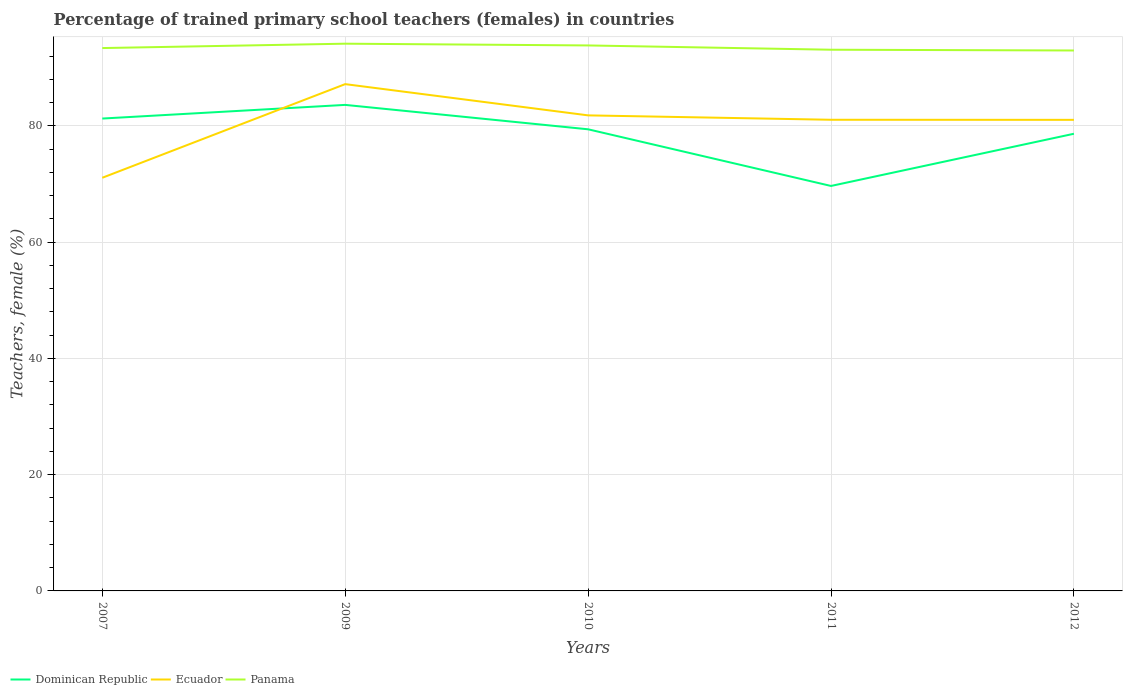Is the number of lines equal to the number of legend labels?
Give a very brief answer. Yes. Across all years, what is the maximum percentage of trained primary school teachers (females) in Panama?
Your answer should be very brief. 92.97. What is the total percentage of trained primary school teachers (females) in Ecuador in the graph?
Ensure brevity in your answer.  0.75. What is the difference between the highest and the second highest percentage of trained primary school teachers (females) in Ecuador?
Make the answer very short. 16.11. Is the percentage of trained primary school teachers (females) in Panama strictly greater than the percentage of trained primary school teachers (females) in Ecuador over the years?
Give a very brief answer. No. How many lines are there?
Your answer should be very brief. 3. How many years are there in the graph?
Offer a terse response. 5. Are the values on the major ticks of Y-axis written in scientific E-notation?
Make the answer very short. No. Does the graph contain any zero values?
Give a very brief answer. No. Does the graph contain grids?
Make the answer very short. Yes. How are the legend labels stacked?
Provide a succinct answer. Horizontal. What is the title of the graph?
Make the answer very short. Percentage of trained primary school teachers (females) in countries. Does "Bolivia" appear as one of the legend labels in the graph?
Your response must be concise. No. What is the label or title of the X-axis?
Give a very brief answer. Years. What is the label or title of the Y-axis?
Offer a terse response. Teachers, female (%). What is the Teachers, female (%) of Dominican Republic in 2007?
Offer a terse response. 81.26. What is the Teachers, female (%) of Ecuador in 2007?
Your answer should be compact. 71.07. What is the Teachers, female (%) of Panama in 2007?
Offer a very short reply. 93.39. What is the Teachers, female (%) in Dominican Republic in 2009?
Your answer should be very brief. 83.61. What is the Teachers, female (%) of Ecuador in 2009?
Provide a succinct answer. 87.18. What is the Teachers, female (%) of Panama in 2009?
Give a very brief answer. 94.14. What is the Teachers, female (%) of Dominican Republic in 2010?
Ensure brevity in your answer.  79.41. What is the Teachers, female (%) in Ecuador in 2010?
Your answer should be compact. 81.81. What is the Teachers, female (%) in Panama in 2010?
Provide a short and direct response. 93.84. What is the Teachers, female (%) in Dominican Republic in 2011?
Your response must be concise. 69.66. What is the Teachers, female (%) in Ecuador in 2011?
Your response must be concise. 81.05. What is the Teachers, female (%) in Panama in 2011?
Keep it short and to the point. 93.1. What is the Teachers, female (%) of Dominican Republic in 2012?
Make the answer very short. 78.64. What is the Teachers, female (%) in Ecuador in 2012?
Keep it short and to the point. 81.04. What is the Teachers, female (%) of Panama in 2012?
Your response must be concise. 92.97. Across all years, what is the maximum Teachers, female (%) of Dominican Republic?
Provide a short and direct response. 83.61. Across all years, what is the maximum Teachers, female (%) of Ecuador?
Ensure brevity in your answer.  87.18. Across all years, what is the maximum Teachers, female (%) of Panama?
Provide a short and direct response. 94.14. Across all years, what is the minimum Teachers, female (%) in Dominican Republic?
Your answer should be compact. 69.66. Across all years, what is the minimum Teachers, female (%) of Ecuador?
Your answer should be very brief. 71.07. Across all years, what is the minimum Teachers, female (%) of Panama?
Your answer should be compact. 92.97. What is the total Teachers, female (%) in Dominican Republic in the graph?
Provide a succinct answer. 392.59. What is the total Teachers, female (%) in Ecuador in the graph?
Provide a short and direct response. 402.15. What is the total Teachers, female (%) in Panama in the graph?
Ensure brevity in your answer.  467.43. What is the difference between the Teachers, female (%) in Dominican Republic in 2007 and that in 2009?
Offer a terse response. -2.35. What is the difference between the Teachers, female (%) of Ecuador in 2007 and that in 2009?
Offer a terse response. -16.11. What is the difference between the Teachers, female (%) in Panama in 2007 and that in 2009?
Keep it short and to the point. -0.75. What is the difference between the Teachers, female (%) of Dominican Republic in 2007 and that in 2010?
Provide a short and direct response. 1.85. What is the difference between the Teachers, female (%) in Ecuador in 2007 and that in 2010?
Make the answer very short. -10.73. What is the difference between the Teachers, female (%) of Panama in 2007 and that in 2010?
Keep it short and to the point. -0.45. What is the difference between the Teachers, female (%) in Dominican Republic in 2007 and that in 2011?
Ensure brevity in your answer.  11.6. What is the difference between the Teachers, female (%) in Ecuador in 2007 and that in 2011?
Your answer should be compact. -9.98. What is the difference between the Teachers, female (%) in Panama in 2007 and that in 2011?
Ensure brevity in your answer.  0.29. What is the difference between the Teachers, female (%) in Dominican Republic in 2007 and that in 2012?
Make the answer very short. 2.62. What is the difference between the Teachers, female (%) of Ecuador in 2007 and that in 2012?
Provide a succinct answer. -9.97. What is the difference between the Teachers, female (%) in Panama in 2007 and that in 2012?
Your answer should be compact. 0.42. What is the difference between the Teachers, female (%) in Dominican Republic in 2009 and that in 2010?
Offer a terse response. 4.2. What is the difference between the Teachers, female (%) in Ecuador in 2009 and that in 2010?
Provide a succinct answer. 5.38. What is the difference between the Teachers, female (%) in Panama in 2009 and that in 2010?
Offer a terse response. 0.3. What is the difference between the Teachers, female (%) of Dominican Republic in 2009 and that in 2011?
Provide a succinct answer. 13.94. What is the difference between the Teachers, female (%) of Ecuador in 2009 and that in 2011?
Your answer should be compact. 6.13. What is the difference between the Teachers, female (%) of Panama in 2009 and that in 2011?
Your answer should be very brief. 1.04. What is the difference between the Teachers, female (%) of Dominican Republic in 2009 and that in 2012?
Keep it short and to the point. 4.97. What is the difference between the Teachers, female (%) in Ecuador in 2009 and that in 2012?
Give a very brief answer. 6.14. What is the difference between the Teachers, female (%) of Panama in 2009 and that in 2012?
Your answer should be very brief. 1.17. What is the difference between the Teachers, female (%) in Dominican Republic in 2010 and that in 2011?
Keep it short and to the point. 9.75. What is the difference between the Teachers, female (%) in Ecuador in 2010 and that in 2011?
Provide a succinct answer. 0.75. What is the difference between the Teachers, female (%) of Panama in 2010 and that in 2011?
Provide a short and direct response. 0.74. What is the difference between the Teachers, female (%) of Dominican Republic in 2010 and that in 2012?
Provide a succinct answer. 0.77. What is the difference between the Teachers, female (%) in Ecuador in 2010 and that in 2012?
Ensure brevity in your answer.  0.77. What is the difference between the Teachers, female (%) in Panama in 2010 and that in 2012?
Your answer should be compact. 0.87. What is the difference between the Teachers, female (%) in Dominican Republic in 2011 and that in 2012?
Ensure brevity in your answer.  -8.98. What is the difference between the Teachers, female (%) of Ecuador in 2011 and that in 2012?
Ensure brevity in your answer.  0.01. What is the difference between the Teachers, female (%) of Panama in 2011 and that in 2012?
Provide a short and direct response. 0.13. What is the difference between the Teachers, female (%) in Dominican Republic in 2007 and the Teachers, female (%) in Ecuador in 2009?
Give a very brief answer. -5.92. What is the difference between the Teachers, female (%) in Dominican Republic in 2007 and the Teachers, female (%) in Panama in 2009?
Your answer should be compact. -12.88. What is the difference between the Teachers, female (%) in Ecuador in 2007 and the Teachers, female (%) in Panama in 2009?
Make the answer very short. -23.06. What is the difference between the Teachers, female (%) in Dominican Republic in 2007 and the Teachers, female (%) in Ecuador in 2010?
Ensure brevity in your answer.  -0.55. What is the difference between the Teachers, female (%) of Dominican Republic in 2007 and the Teachers, female (%) of Panama in 2010?
Your answer should be compact. -12.58. What is the difference between the Teachers, female (%) in Ecuador in 2007 and the Teachers, female (%) in Panama in 2010?
Give a very brief answer. -22.76. What is the difference between the Teachers, female (%) in Dominican Republic in 2007 and the Teachers, female (%) in Ecuador in 2011?
Your response must be concise. 0.21. What is the difference between the Teachers, female (%) of Dominican Republic in 2007 and the Teachers, female (%) of Panama in 2011?
Your response must be concise. -11.84. What is the difference between the Teachers, female (%) of Ecuador in 2007 and the Teachers, female (%) of Panama in 2011?
Keep it short and to the point. -22.03. What is the difference between the Teachers, female (%) of Dominican Republic in 2007 and the Teachers, female (%) of Ecuador in 2012?
Give a very brief answer. 0.22. What is the difference between the Teachers, female (%) in Dominican Republic in 2007 and the Teachers, female (%) in Panama in 2012?
Your answer should be very brief. -11.71. What is the difference between the Teachers, female (%) of Ecuador in 2007 and the Teachers, female (%) of Panama in 2012?
Give a very brief answer. -21.9. What is the difference between the Teachers, female (%) of Dominican Republic in 2009 and the Teachers, female (%) of Ecuador in 2010?
Ensure brevity in your answer.  1.8. What is the difference between the Teachers, female (%) in Dominican Republic in 2009 and the Teachers, female (%) in Panama in 2010?
Make the answer very short. -10.23. What is the difference between the Teachers, female (%) in Ecuador in 2009 and the Teachers, female (%) in Panama in 2010?
Ensure brevity in your answer.  -6.66. What is the difference between the Teachers, female (%) of Dominican Republic in 2009 and the Teachers, female (%) of Ecuador in 2011?
Provide a short and direct response. 2.56. What is the difference between the Teachers, female (%) in Dominican Republic in 2009 and the Teachers, female (%) in Panama in 2011?
Provide a short and direct response. -9.49. What is the difference between the Teachers, female (%) in Ecuador in 2009 and the Teachers, female (%) in Panama in 2011?
Provide a short and direct response. -5.92. What is the difference between the Teachers, female (%) in Dominican Republic in 2009 and the Teachers, female (%) in Ecuador in 2012?
Give a very brief answer. 2.57. What is the difference between the Teachers, female (%) in Dominican Republic in 2009 and the Teachers, female (%) in Panama in 2012?
Offer a terse response. -9.36. What is the difference between the Teachers, female (%) of Ecuador in 2009 and the Teachers, female (%) of Panama in 2012?
Provide a short and direct response. -5.79. What is the difference between the Teachers, female (%) in Dominican Republic in 2010 and the Teachers, female (%) in Ecuador in 2011?
Provide a short and direct response. -1.64. What is the difference between the Teachers, female (%) in Dominican Republic in 2010 and the Teachers, female (%) in Panama in 2011?
Provide a short and direct response. -13.69. What is the difference between the Teachers, female (%) in Ecuador in 2010 and the Teachers, female (%) in Panama in 2011?
Make the answer very short. -11.29. What is the difference between the Teachers, female (%) of Dominican Republic in 2010 and the Teachers, female (%) of Ecuador in 2012?
Your answer should be compact. -1.63. What is the difference between the Teachers, female (%) of Dominican Republic in 2010 and the Teachers, female (%) of Panama in 2012?
Provide a succinct answer. -13.56. What is the difference between the Teachers, female (%) in Ecuador in 2010 and the Teachers, female (%) in Panama in 2012?
Provide a short and direct response. -11.16. What is the difference between the Teachers, female (%) of Dominican Republic in 2011 and the Teachers, female (%) of Ecuador in 2012?
Keep it short and to the point. -11.37. What is the difference between the Teachers, female (%) in Dominican Republic in 2011 and the Teachers, female (%) in Panama in 2012?
Offer a very short reply. -23.3. What is the difference between the Teachers, female (%) of Ecuador in 2011 and the Teachers, female (%) of Panama in 2012?
Give a very brief answer. -11.92. What is the average Teachers, female (%) in Dominican Republic per year?
Provide a succinct answer. 78.52. What is the average Teachers, female (%) of Ecuador per year?
Provide a succinct answer. 80.43. What is the average Teachers, female (%) of Panama per year?
Provide a succinct answer. 93.49. In the year 2007, what is the difference between the Teachers, female (%) in Dominican Republic and Teachers, female (%) in Ecuador?
Your answer should be compact. 10.19. In the year 2007, what is the difference between the Teachers, female (%) in Dominican Republic and Teachers, female (%) in Panama?
Ensure brevity in your answer.  -12.13. In the year 2007, what is the difference between the Teachers, female (%) of Ecuador and Teachers, female (%) of Panama?
Offer a very short reply. -22.31. In the year 2009, what is the difference between the Teachers, female (%) in Dominican Republic and Teachers, female (%) in Ecuador?
Provide a short and direct response. -3.57. In the year 2009, what is the difference between the Teachers, female (%) in Dominican Republic and Teachers, female (%) in Panama?
Your answer should be very brief. -10.53. In the year 2009, what is the difference between the Teachers, female (%) in Ecuador and Teachers, female (%) in Panama?
Provide a succinct answer. -6.96. In the year 2010, what is the difference between the Teachers, female (%) in Dominican Republic and Teachers, female (%) in Ecuador?
Offer a terse response. -2.4. In the year 2010, what is the difference between the Teachers, female (%) of Dominican Republic and Teachers, female (%) of Panama?
Your answer should be compact. -14.43. In the year 2010, what is the difference between the Teachers, female (%) of Ecuador and Teachers, female (%) of Panama?
Your answer should be compact. -12.03. In the year 2011, what is the difference between the Teachers, female (%) of Dominican Republic and Teachers, female (%) of Ecuador?
Provide a succinct answer. -11.39. In the year 2011, what is the difference between the Teachers, female (%) of Dominican Republic and Teachers, female (%) of Panama?
Provide a succinct answer. -23.43. In the year 2011, what is the difference between the Teachers, female (%) of Ecuador and Teachers, female (%) of Panama?
Ensure brevity in your answer.  -12.05. In the year 2012, what is the difference between the Teachers, female (%) in Dominican Republic and Teachers, female (%) in Ecuador?
Ensure brevity in your answer.  -2.39. In the year 2012, what is the difference between the Teachers, female (%) in Dominican Republic and Teachers, female (%) in Panama?
Provide a short and direct response. -14.33. In the year 2012, what is the difference between the Teachers, female (%) of Ecuador and Teachers, female (%) of Panama?
Your answer should be compact. -11.93. What is the ratio of the Teachers, female (%) in Dominican Republic in 2007 to that in 2009?
Give a very brief answer. 0.97. What is the ratio of the Teachers, female (%) in Ecuador in 2007 to that in 2009?
Your response must be concise. 0.82. What is the ratio of the Teachers, female (%) of Panama in 2007 to that in 2009?
Your response must be concise. 0.99. What is the ratio of the Teachers, female (%) of Dominican Republic in 2007 to that in 2010?
Offer a very short reply. 1.02. What is the ratio of the Teachers, female (%) in Ecuador in 2007 to that in 2010?
Offer a terse response. 0.87. What is the ratio of the Teachers, female (%) in Panama in 2007 to that in 2010?
Make the answer very short. 1. What is the ratio of the Teachers, female (%) of Dominican Republic in 2007 to that in 2011?
Give a very brief answer. 1.17. What is the ratio of the Teachers, female (%) of Ecuador in 2007 to that in 2011?
Your answer should be compact. 0.88. What is the ratio of the Teachers, female (%) in Ecuador in 2007 to that in 2012?
Provide a succinct answer. 0.88. What is the ratio of the Teachers, female (%) in Panama in 2007 to that in 2012?
Your answer should be very brief. 1. What is the ratio of the Teachers, female (%) in Dominican Republic in 2009 to that in 2010?
Provide a short and direct response. 1.05. What is the ratio of the Teachers, female (%) in Ecuador in 2009 to that in 2010?
Your answer should be compact. 1.07. What is the ratio of the Teachers, female (%) in Panama in 2009 to that in 2010?
Offer a terse response. 1. What is the ratio of the Teachers, female (%) of Dominican Republic in 2009 to that in 2011?
Provide a succinct answer. 1.2. What is the ratio of the Teachers, female (%) in Ecuador in 2009 to that in 2011?
Keep it short and to the point. 1.08. What is the ratio of the Teachers, female (%) in Panama in 2009 to that in 2011?
Provide a short and direct response. 1.01. What is the ratio of the Teachers, female (%) of Dominican Republic in 2009 to that in 2012?
Offer a very short reply. 1.06. What is the ratio of the Teachers, female (%) of Ecuador in 2009 to that in 2012?
Ensure brevity in your answer.  1.08. What is the ratio of the Teachers, female (%) in Panama in 2009 to that in 2012?
Your answer should be compact. 1.01. What is the ratio of the Teachers, female (%) of Dominican Republic in 2010 to that in 2011?
Your response must be concise. 1.14. What is the ratio of the Teachers, female (%) of Ecuador in 2010 to that in 2011?
Ensure brevity in your answer.  1.01. What is the ratio of the Teachers, female (%) of Panama in 2010 to that in 2011?
Keep it short and to the point. 1.01. What is the ratio of the Teachers, female (%) of Dominican Republic in 2010 to that in 2012?
Provide a succinct answer. 1.01. What is the ratio of the Teachers, female (%) in Ecuador in 2010 to that in 2012?
Offer a very short reply. 1.01. What is the ratio of the Teachers, female (%) in Panama in 2010 to that in 2012?
Offer a terse response. 1.01. What is the ratio of the Teachers, female (%) in Dominican Republic in 2011 to that in 2012?
Ensure brevity in your answer.  0.89. What is the ratio of the Teachers, female (%) of Ecuador in 2011 to that in 2012?
Offer a very short reply. 1. What is the difference between the highest and the second highest Teachers, female (%) of Dominican Republic?
Offer a terse response. 2.35. What is the difference between the highest and the second highest Teachers, female (%) of Ecuador?
Your response must be concise. 5.38. What is the difference between the highest and the second highest Teachers, female (%) of Panama?
Provide a short and direct response. 0.3. What is the difference between the highest and the lowest Teachers, female (%) in Dominican Republic?
Give a very brief answer. 13.94. What is the difference between the highest and the lowest Teachers, female (%) in Ecuador?
Your answer should be very brief. 16.11. What is the difference between the highest and the lowest Teachers, female (%) in Panama?
Ensure brevity in your answer.  1.17. 